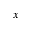Convert formula to latex. <formula><loc_0><loc_0><loc_500><loc_500>x</formula> 